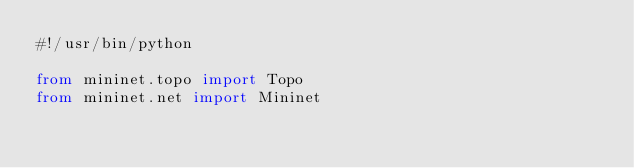Convert code to text. <code><loc_0><loc_0><loc_500><loc_500><_Python_>#!/usr/bin/python

from mininet.topo import Topo
from mininet.net import Mininet</code> 